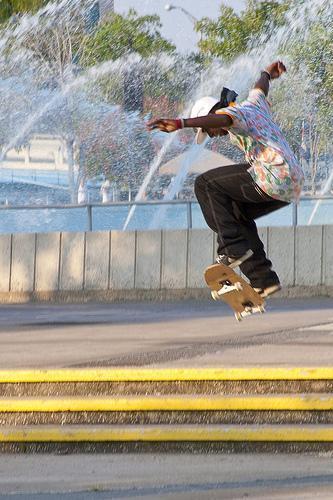How many people are in the photo?
Give a very brief answer. 1. 